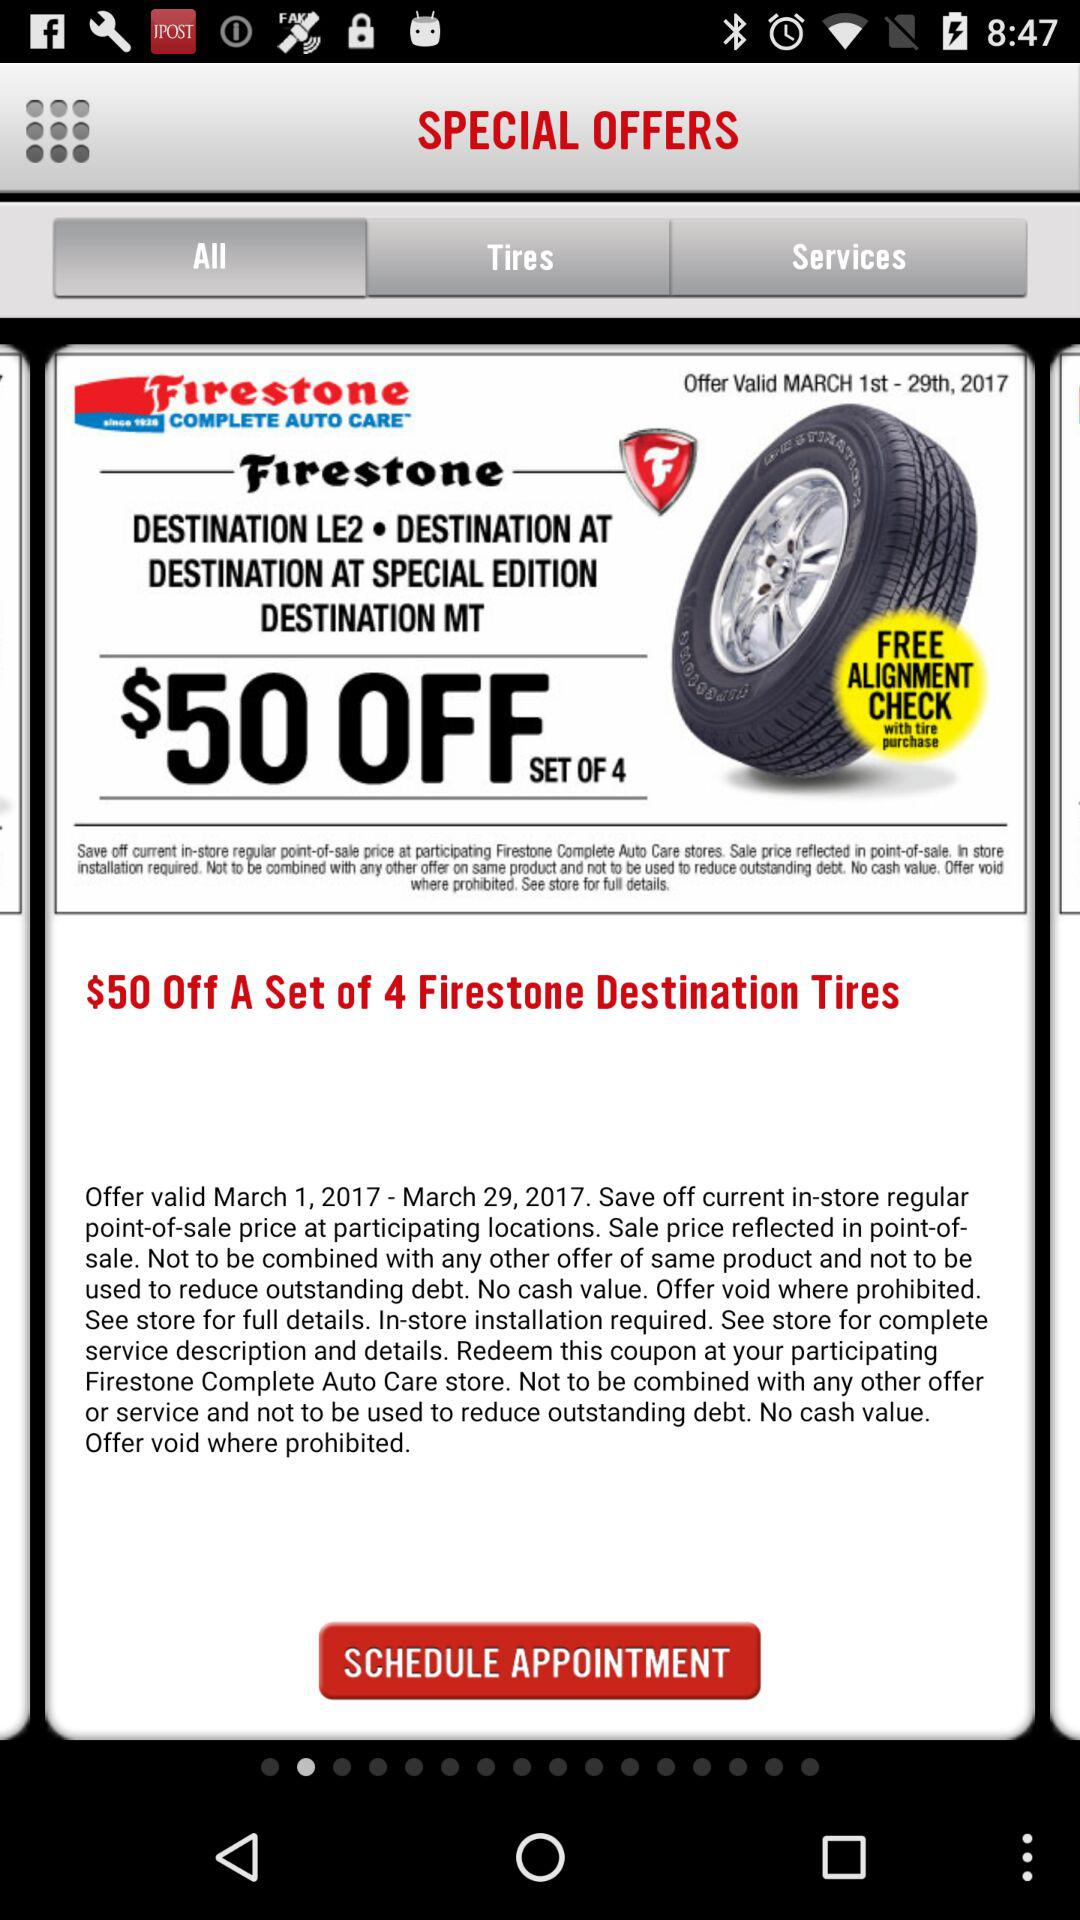When does the offer expire? The offer expires on March 29, 2017. 